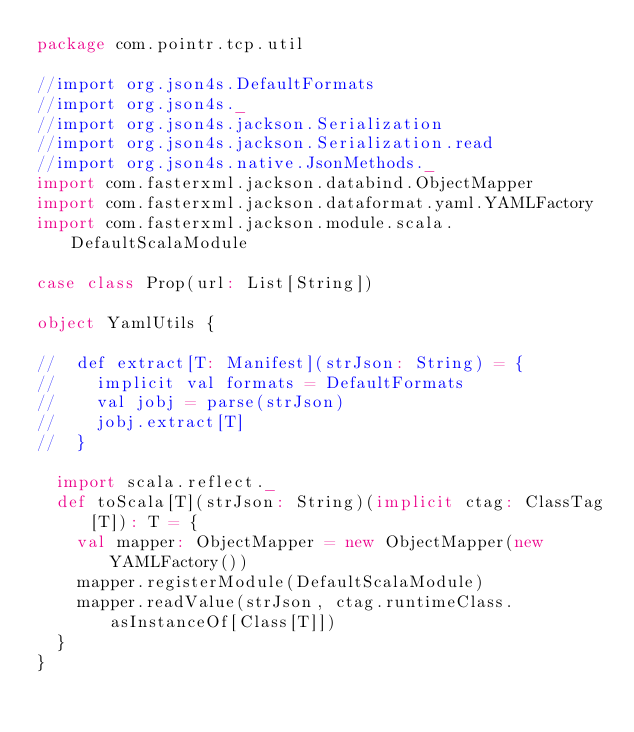<code> <loc_0><loc_0><loc_500><loc_500><_Scala_>package com.pointr.tcp.util

//import org.json4s.DefaultFormats
//import org.json4s._
//import org.json4s.jackson.Serialization
//import org.json4s.jackson.Serialization.read
//import org.json4s.native.JsonMethods._
import com.fasterxml.jackson.databind.ObjectMapper
import com.fasterxml.jackson.dataformat.yaml.YAMLFactory
import com.fasterxml.jackson.module.scala.DefaultScalaModule

case class Prop(url: List[String])

object YamlUtils {

//  def extract[T: Manifest](strJson: String) = {
//    implicit val formats = DefaultFormats
//    val jobj = parse(strJson)
//    jobj.extract[T]
//  }

  import scala.reflect._
  def toScala[T](strJson: String)(implicit ctag: ClassTag[T]): T = {
    val mapper: ObjectMapper = new ObjectMapper(new YAMLFactory())
    mapper.registerModule(DefaultScalaModule)
    mapper.readValue(strJson, ctag.runtimeClass.asInstanceOf[Class[T]])
  }
}




</code> 